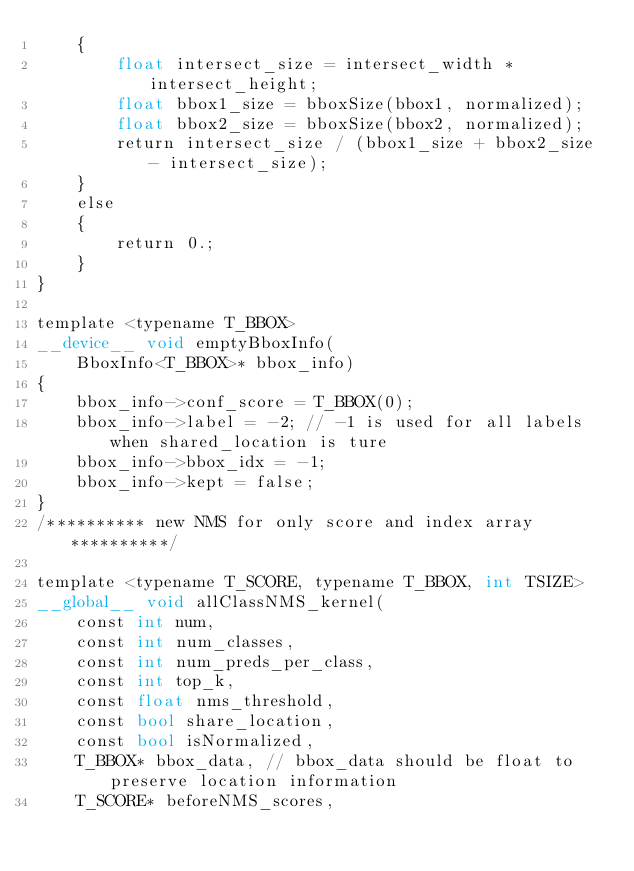Convert code to text. <code><loc_0><loc_0><loc_500><loc_500><_Cuda_>    {
        float intersect_size = intersect_width * intersect_height;
        float bbox1_size = bboxSize(bbox1, normalized);
        float bbox2_size = bboxSize(bbox2, normalized);
        return intersect_size / (bbox1_size + bbox2_size - intersect_size);
    }
    else
    {
        return 0.;
    }
}

template <typename T_BBOX>
__device__ void emptyBboxInfo(
    BboxInfo<T_BBOX>* bbox_info)
{
    bbox_info->conf_score = T_BBOX(0);
    bbox_info->label = -2; // -1 is used for all labels when shared_location is ture
    bbox_info->bbox_idx = -1;
    bbox_info->kept = false;
}
/********** new NMS for only score and index array **********/

template <typename T_SCORE, typename T_BBOX, int TSIZE>
__global__ void allClassNMS_kernel(
    const int num,
    const int num_classes,
    const int num_preds_per_class,
    const int top_k,
    const float nms_threshold,
    const bool share_location,
    const bool isNormalized,
    T_BBOX* bbox_data, // bbox_data should be float to preserve location information
    T_SCORE* beforeNMS_scores,</code> 